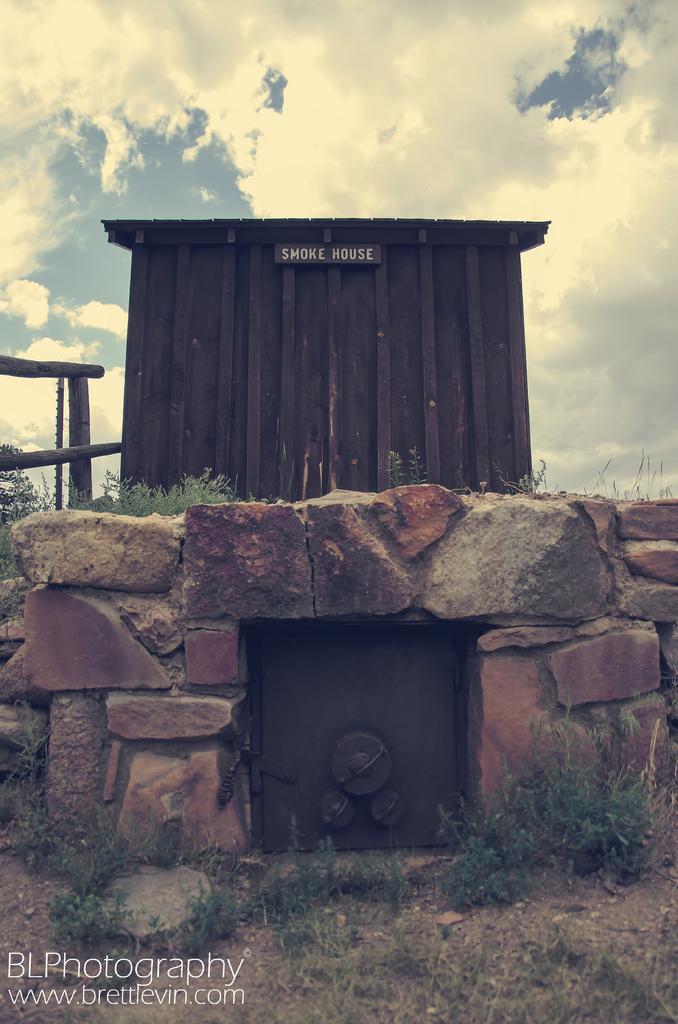Can you describe this image briefly? In this image in the center there is one shelter, and at the bottom there is a wall and some board and on the left side there are some wooden sticks. At the bottom there is grass and sand and at the top of the image there is sky. 